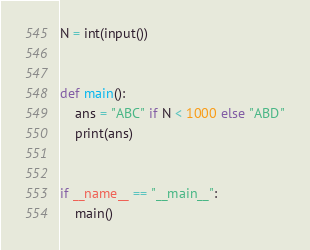<code> <loc_0><loc_0><loc_500><loc_500><_Python_>N = int(input())


def main():
    ans = "ABC" if N < 1000 else "ABD"
    print(ans)


if __name__ == "__main__":
    main()
</code> 